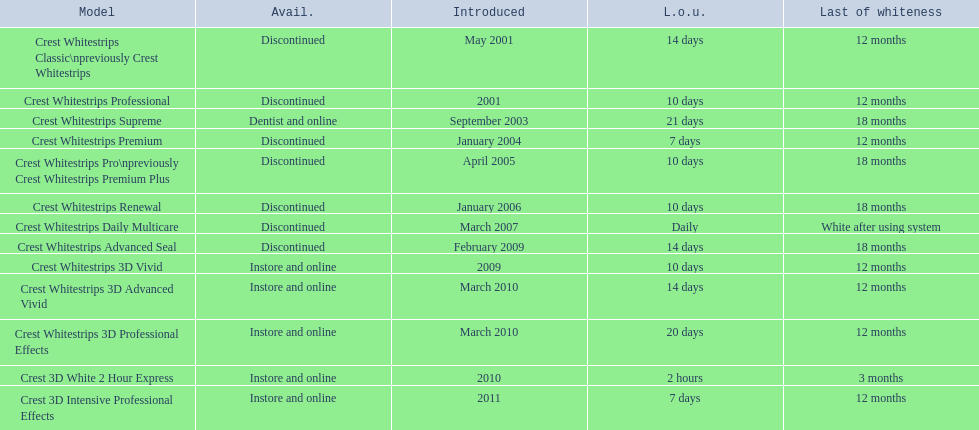What year did crest come out with crest white strips 3d vivid? 2009. Which crest product was also introduced he same year, but is now discontinued? Crest Whitestrips Advanced Seal. 